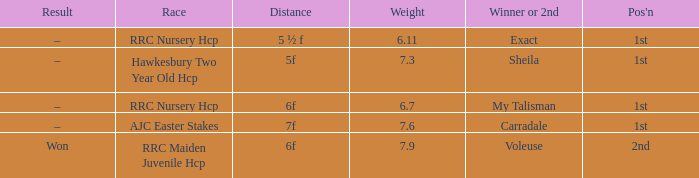What was the name of the winner or 2nd when the result was –, and weight was 6.7? My Talisman. 